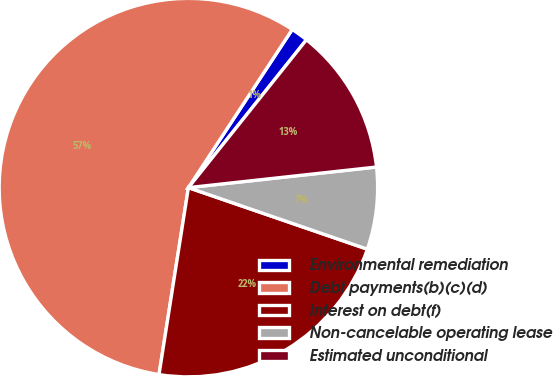<chart> <loc_0><loc_0><loc_500><loc_500><pie_chart><fcel>Environmental remediation<fcel>Debt payments(b)(c)(d)<fcel>Interest on debt(f)<fcel>Non-cancelable operating lease<fcel>Estimated unconditional<nl><fcel>1.48%<fcel>56.76%<fcel>22.21%<fcel>7.01%<fcel>12.54%<nl></chart> 